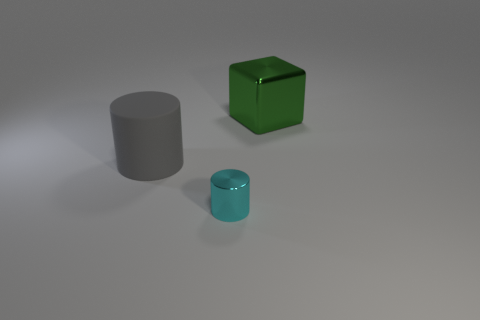Add 1 cyan cylinders. How many objects exist? 4 Subtract 1 cubes. How many cubes are left? 0 Add 1 big shiny cubes. How many big shiny cubes are left? 2 Add 2 small purple cylinders. How many small purple cylinders exist? 2 Subtract 1 cyan cylinders. How many objects are left? 2 Subtract all cubes. How many objects are left? 2 Subtract all yellow cubes. Subtract all yellow spheres. How many cubes are left? 1 Subtract all brown spheres. How many cyan cylinders are left? 1 Subtract all big cylinders. Subtract all large shiny blocks. How many objects are left? 1 